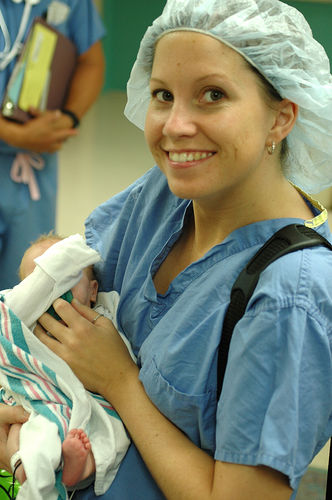Can you describe the emotions conveyed in the image? The image radiates a sense of joy and tenderness. The woman is smiling broadly, suggesting happiness or pride, likely related to the newborn she is holding. Her body language, with the gentle way she cradles the baby, also conveys a feeling of care and protection. The newborn appears calm and secure in her arms, adding to the emotional warmth of the photo. 